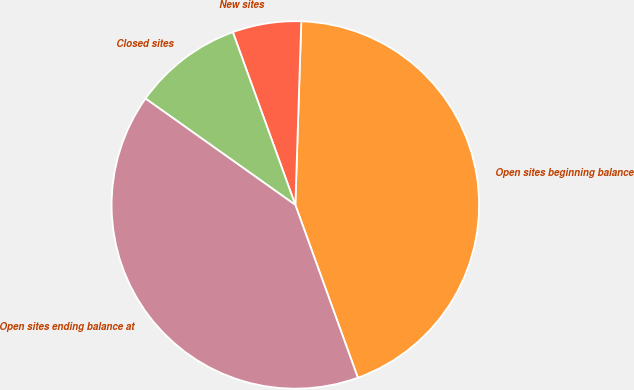<chart> <loc_0><loc_0><loc_500><loc_500><pie_chart><fcel>Open sites beginning balance<fcel>New sites<fcel>Closed sites<fcel>Open sites ending balance at<nl><fcel>43.96%<fcel>6.04%<fcel>9.65%<fcel>40.35%<nl></chart> 